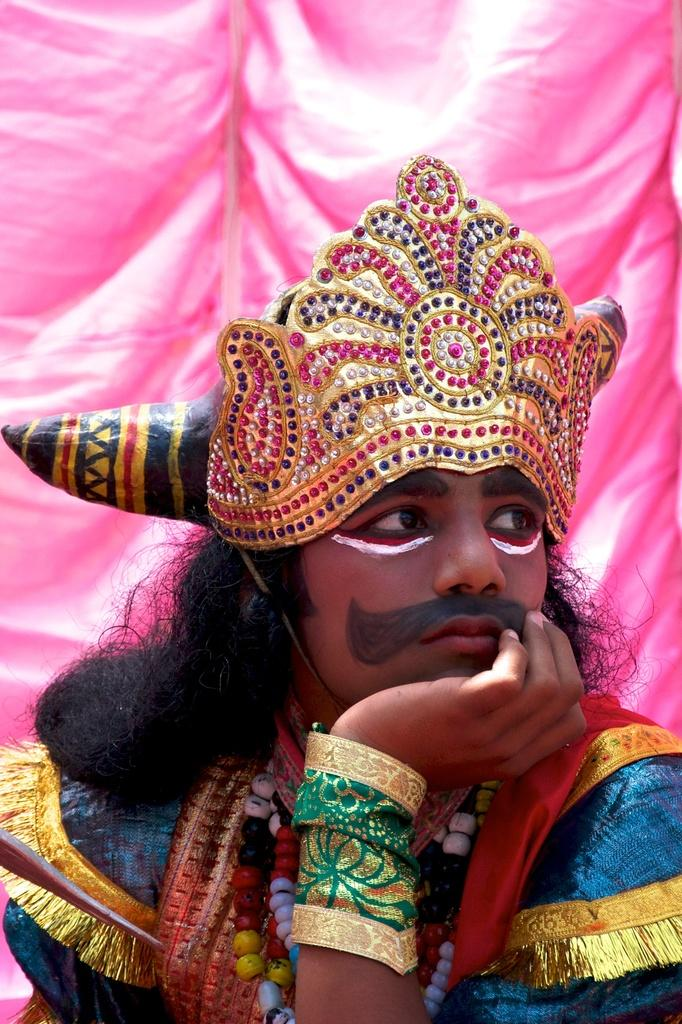What is the main subject of the image? There is a person in the image. What is the person wearing on their head? The person is wearing a crown. What other accessories can be seen on the person? The person is wearing pearl chains. What is the person holding in their hand? There is a cloth on the person's hand. How is the person's face decorated? The person's face is painted. What can be seen in the background of the image? There is a pink curtain in the background of the image. What type of doctor is treating the person in the image? There is no doctor present in the image; it features a person wearing a crown, pearl chains, and a painted face. Is the person in the image experiencing a rainstorm? There is no indication of a rainstorm in the image; it is focused on the person and their attire. 